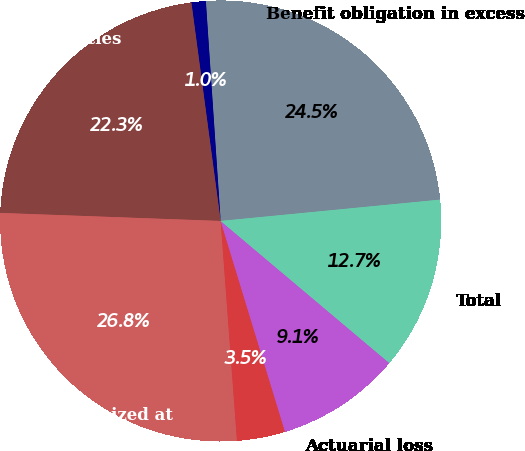Convert chart. <chart><loc_0><loc_0><loc_500><loc_500><pie_chart><fcel>Benefit obligation in excess<fcel>Current liabilities<fcel>Noncurrent liabilities<fcel>Accrued benefit recognized at<fcel>Prior service cost<fcel>Actuarial loss<fcel>Total<nl><fcel>24.53%<fcel>1.05%<fcel>22.3%<fcel>26.76%<fcel>3.54%<fcel>9.14%<fcel>12.68%<nl></chart> 